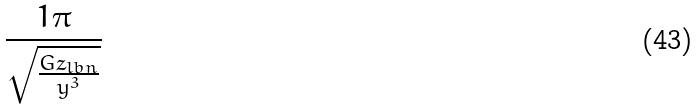Convert formula to latex. <formula><loc_0><loc_0><loc_500><loc_500>\frac { 1 \pi } { \sqrt { \frac { G z _ { l b n } } { y ^ { 3 } } } }</formula> 